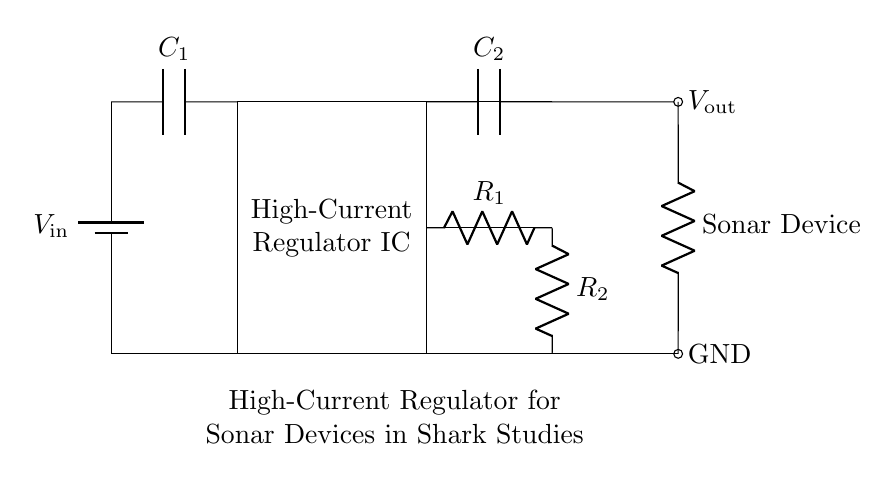What is the input voltage for this circuit? The circuit shows the input voltage labeled as V_in connected to the battery symbol, indicating that the input voltage is supplied by a battery.
Answer: V_in What type of regulator is used in this circuit? The circuit diagram specifies a component labeled as "High-Current Regulator IC." This indicates that the circuit uses a high-current specific integrated circuit designed to regulate voltage levels.
Answer: High-Current Regulator IC How many capacitors are present in the circuit? By observing the diagram, there are two capacitors labeled C_1 and C_2. Their presence is noted between specified points in the circuit, contributing to voltage stability and filtering.
Answer: 2 What is the load connected to the output of the regulator? The circuit shows a resistor labeled "Sonar Device" connected to the output. The label indicates that the load is specifically a sonar device used in studies, as intended by the circuit design.
Answer: Sonar Device What is the purpose of the resistors R_1 and R_2? The resistors R_1 and R_2 are used in feedback configuration to help regulate the output voltage by dividing the voltage and sending a feedback signal to the regulator IC. This configuration stabilizes the regulated output voltage.
Answer: Feedback What is the primary function of the input capacitor C_1? Capacitor C_1 is connected at the input and functions primarily as a filter to smooth out any fluctuations in the input voltage supplied to the regulator. This ensures stable operation of the regulator by providing adequate charge.
Answer: Smoothing What is connected at the GND terminal of the circuit? The GND terminal is connected to the negative side of the load (Sonar Device) and represents the ground reference point for the entire circuit, providing a common return path for current.
Answer: Ground Reference 